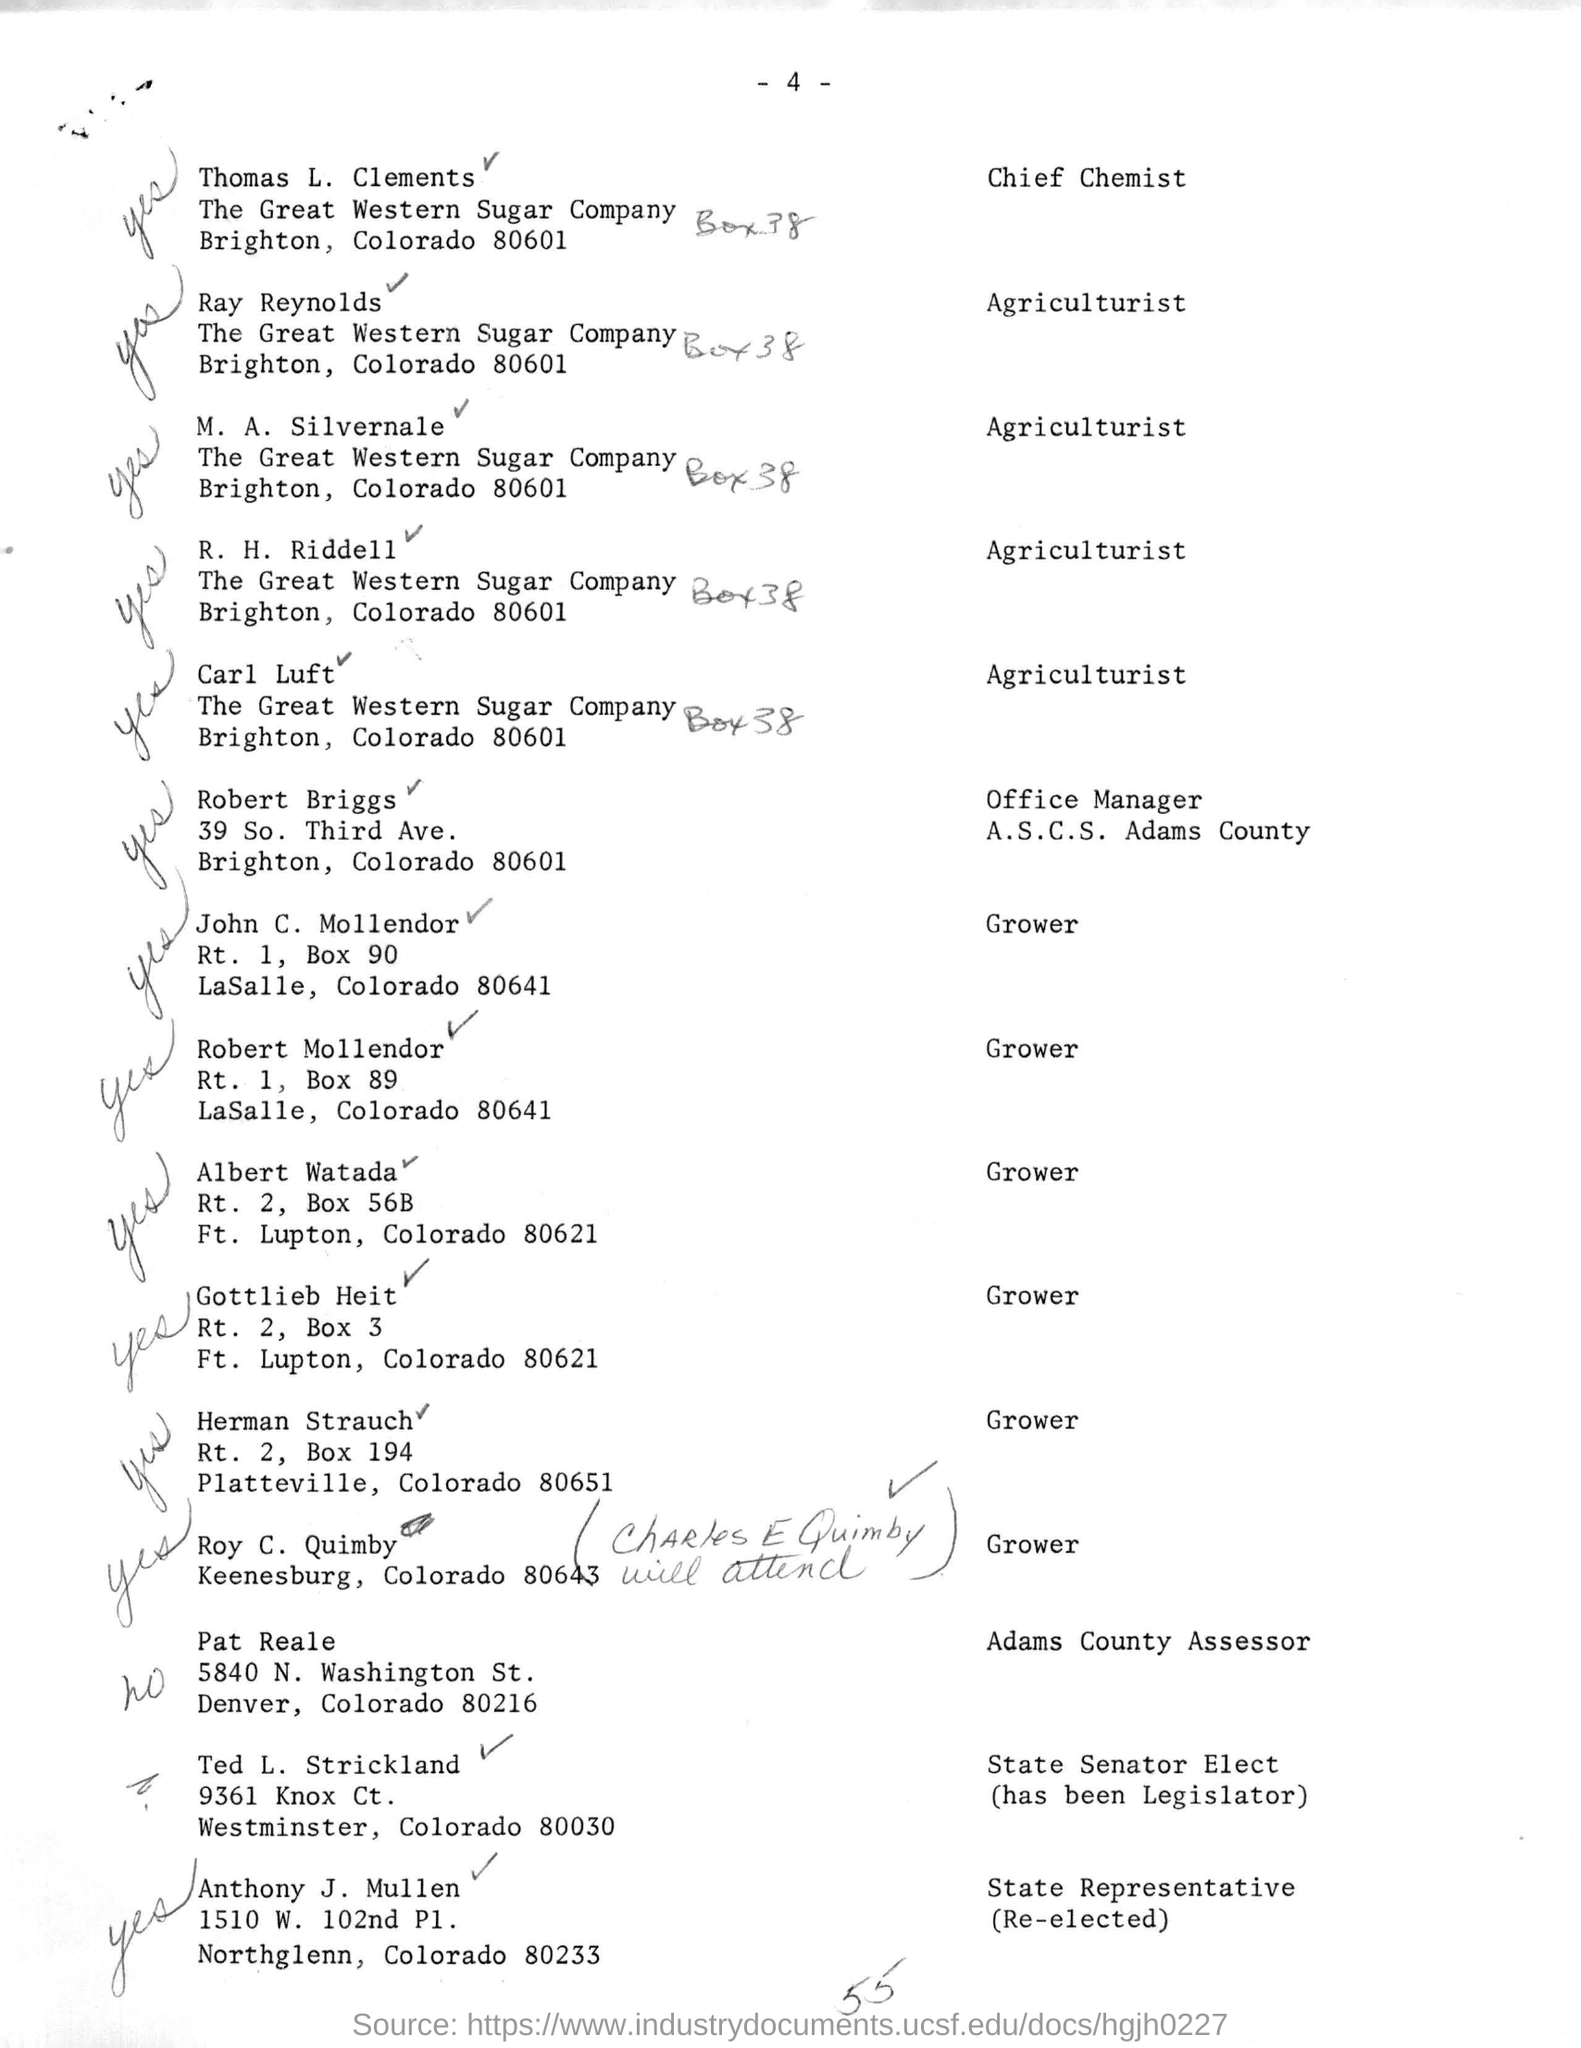Specify some key components in this picture. Pat Reale is the name of the Adams County assessor mentioned. The office manager named Robert Briggs was mentioned. I would like to inquire about the name of the state representative mentioned, specifically Anthony J. Mullen. The chief chemist named Thomas L. Clements is mentioned. 